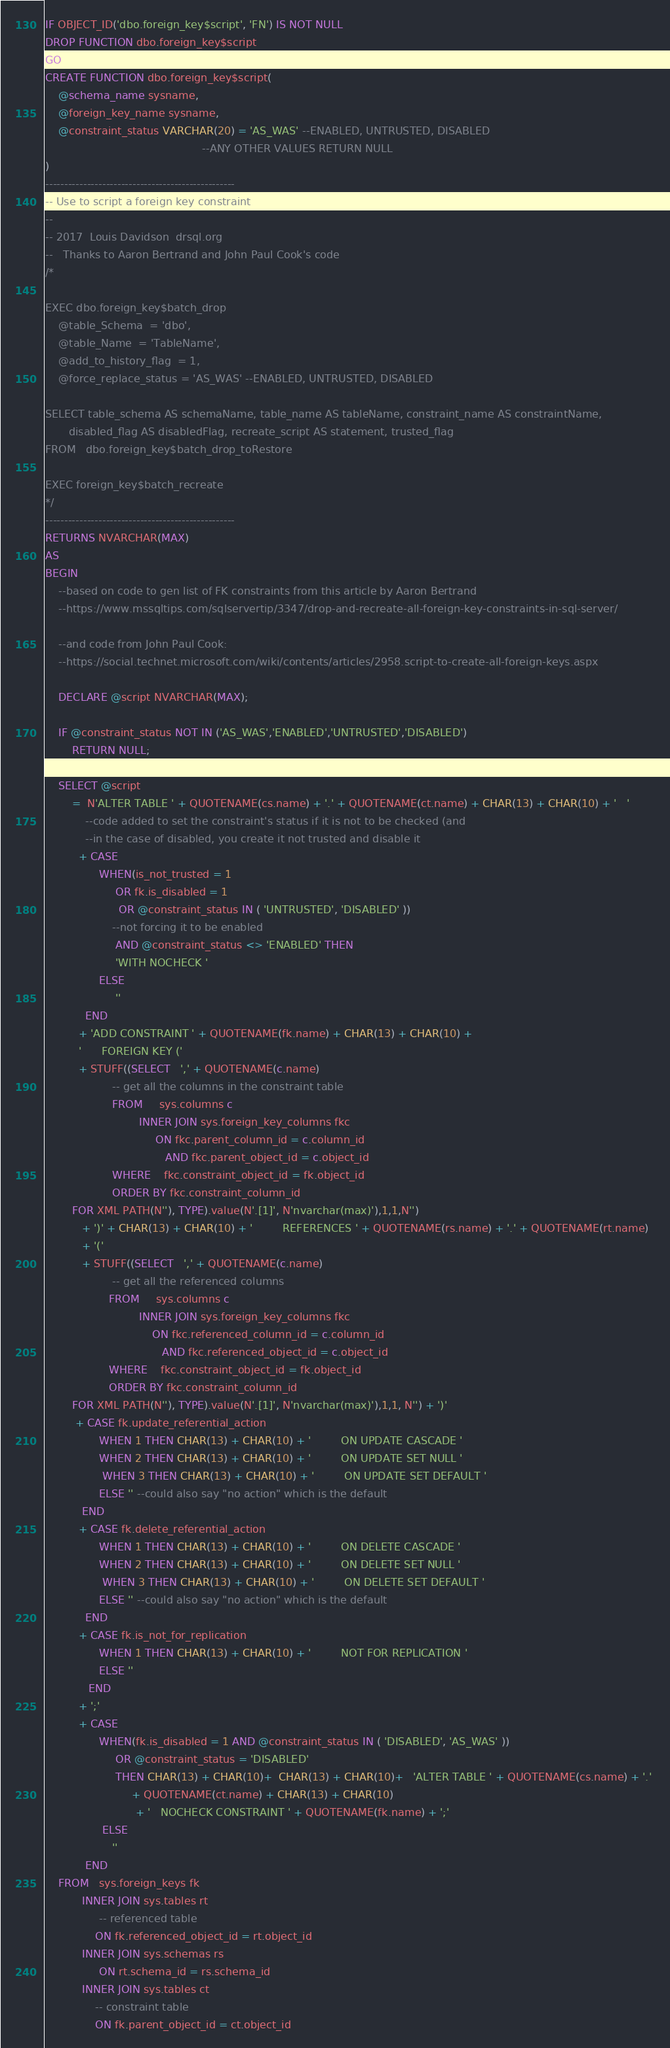Convert code to text. <code><loc_0><loc_0><loc_500><loc_500><_SQL_>IF OBJECT_ID('dbo.foreign_key$script', 'FN') IS NOT NULL
DROP FUNCTION dbo.foreign_key$script
GO
CREATE FUNCTION dbo.foreign_key$script( 
    @schema_name sysname, 
    @foreign_key_name sysname, 
    @constraint_status VARCHAR(20) = 'AS_WAS' --ENABLED, UNTRUSTED, DISABLED 
                                               --ANY OTHER VALUES RETURN NULL 
) 
-------------------------------------------------- 
-- Use to script a foreign key constraint 
-- 
-- 2017  Louis Davidson  drsql.org 
--   Thanks to Aaron Bertrand and John Paul Cook's code 
/*

EXEC dbo.foreign_key$batch_drop
    @table_Schema  = 'dbo', 
    @table_Name  = 'TableName', 
    @add_to_history_flag  = 1, 
    @force_replace_status = 'AS_WAS' --ENABLED, UNTRUSTED, DISABLED 

SELECT table_schema AS schemaName, table_name AS tableName, constraint_name AS constraintName, 
	   disabled_flag AS disabledFlag, recreate_script AS statement, trusted_flag 
FROM   dbo.foreign_key$batch_drop_toRestore

EXEC foreign_key$batch_recreate        
*/
-------------------------------------------------- 
RETURNS NVARCHAR(MAX) 
AS 
BEGIN 
    --based on code to gen list of FK constraints from this article by Aaron Bertrand 
    --https://www.mssqltips.com/sqlservertip/3347/drop-and-recreate-all-foreign-key-constraints-in-sql-server/

    --and code from John Paul Cook: 
    --https://social.technet.microsoft.com/wiki/contents/articles/2958.script-to-create-all-foreign-keys.aspx

    DECLARE @script NVARCHAR(MAX);

    IF @constraint_status NOT IN ('AS_WAS','ENABLED','UNTRUSTED','DISABLED') 
        RETURN NULL;

    SELECT @script 
        =  N'ALTER TABLE ' + QUOTENAME(cs.name) + '.' + QUOTENAME(ct.name) + CHAR(13) + CHAR(10) + '   ' 
            --code added to set the constraint's status if it is not to be checked (and 
            --in the case of disabled, you create it not trusted and disable it 
          + CASE 
                WHEN(is_not_trusted = 1 
                     OR fk.is_disabled = 1 
                      OR @constraint_status IN ( 'UNTRUSTED', 'DISABLED' )) 
                    --not forcing it to be enabled 
                     AND @constraint_status <> 'ENABLED' THEN 
                     'WITH NOCHECK ' 
                ELSE 
                     '' 
            END 
          + 'ADD CONSTRAINT ' + QUOTENAME(fk.name) + CHAR(13) + CHAR(10) + 
          '      FOREIGN KEY (' 
          + STUFF((SELECT   ',' + QUOTENAME(c.name) 
                    -- get all the columns in the constraint table 
                    FROM     sys.columns c 
                            INNER JOIN sys.foreign_key_columns fkc 
                                 ON fkc.parent_column_id = c.column_id 
                                    AND fkc.parent_object_id = c.object_id 
                    WHERE    fkc.constraint_object_id = fk.object_id 
                    ORDER BY fkc.constraint_column_id 
        FOR XML PATH(N''), TYPE).value(N'.[1]', N'nvarchar(max)'),1,1,N'') 
           + ')' + CHAR(13) + CHAR(10) + '         REFERENCES ' + QUOTENAME(rs.name) + '.' + QUOTENAME(rt.name) 
           + '(' 
           + STUFF((SELECT   ',' + QUOTENAME(c.name) 
                    -- get all the referenced columns 
                   FROM     sys.columns c 
                            INNER JOIN sys.foreign_key_columns fkc 
                                ON fkc.referenced_column_id = c.column_id 
                                   AND fkc.referenced_object_id = c.object_id 
                   WHERE    fkc.constraint_object_id = fk.object_id 
                   ORDER BY fkc.constraint_column_id 
        FOR XML PATH(N''), TYPE).value(N'.[1]', N'nvarchar(max)'),1,1, N'') + ')' 
         + CASE fk.update_referential_action 
                WHEN 1 THEN CHAR(13) + CHAR(10) + '         ON UPDATE CASCADE ' 
                WHEN 2 THEN CHAR(13) + CHAR(10) + '         ON UPDATE SET NULL ' 
                 WHEN 3 THEN CHAR(13) + CHAR(10) + '         ON UPDATE SET DEFAULT ' 
                ELSE '' --could also say "no action" which is the default 
           END 
          + CASE fk.delete_referential_action 
                WHEN 1 THEN CHAR(13) + CHAR(10) + '         ON DELETE CASCADE ' 
                WHEN 2 THEN CHAR(13) + CHAR(10) + '         ON DELETE SET NULL ' 
                 WHEN 3 THEN CHAR(13) + CHAR(10) + '         ON DELETE SET DEFAULT ' 
                ELSE '' --could also say "no action" which is the default 
            END 
          + CASE fk.is_not_for_replication 
                WHEN 1 THEN CHAR(13) + CHAR(10) + '         NOT FOR REPLICATION ' 
                ELSE '' 
             END 
          + ';' 
          + CASE 
                WHEN(fk.is_disabled = 1 AND @constraint_status IN ( 'DISABLED', 'AS_WAS' )) 
                     OR @constraint_status = 'DISABLED' 
                     THEN CHAR(13) + CHAR(10)+  CHAR(13) + CHAR(10)+   'ALTER TABLE ' + QUOTENAME(cs.name) + '.' 
                          + QUOTENAME(ct.name) + CHAR(13) + CHAR(10) 
                           + '   NOCHECK CONSTRAINT ' + QUOTENAME(fk.name) + ';' 
                 ELSE 
                    '' 
            END 
    FROM   sys.foreign_keys fk 
           INNER JOIN sys.tables rt 
                -- referenced table 
               ON fk.referenced_object_id = rt.object_id 
           INNER JOIN sys.schemas rs 
                ON rt.schema_id = rs.schema_id 
           INNER JOIN sys.tables ct 
               -- constraint table 
               ON fk.parent_object_id = ct.object_id </code> 